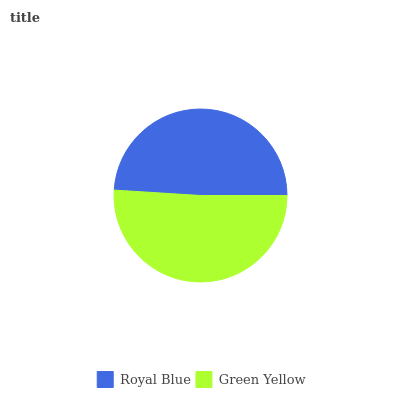Is Royal Blue the minimum?
Answer yes or no. Yes. Is Green Yellow the maximum?
Answer yes or no. Yes. Is Green Yellow the minimum?
Answer yes or no. No. Is Green Yellow greater than Royal Blue?
Answer yes or no. Yes. Is Royal Blue less than Green Yellow?
Answer yes or no. Yes. Is Royal Blue greater than Green Yellow?
Answer yes or no. No. Is Green Yellow less than Royal Blue?
Answer yes or no. No. Is Green Yellow the high median?
Answer yes or no. Yes. Is Royal Blue the low median?
Answer yes or no. Yes. Is Royal Blue the high median?
Answer yes or no. No. Is Green Yellow the low median?
Answer yes or no. No. 